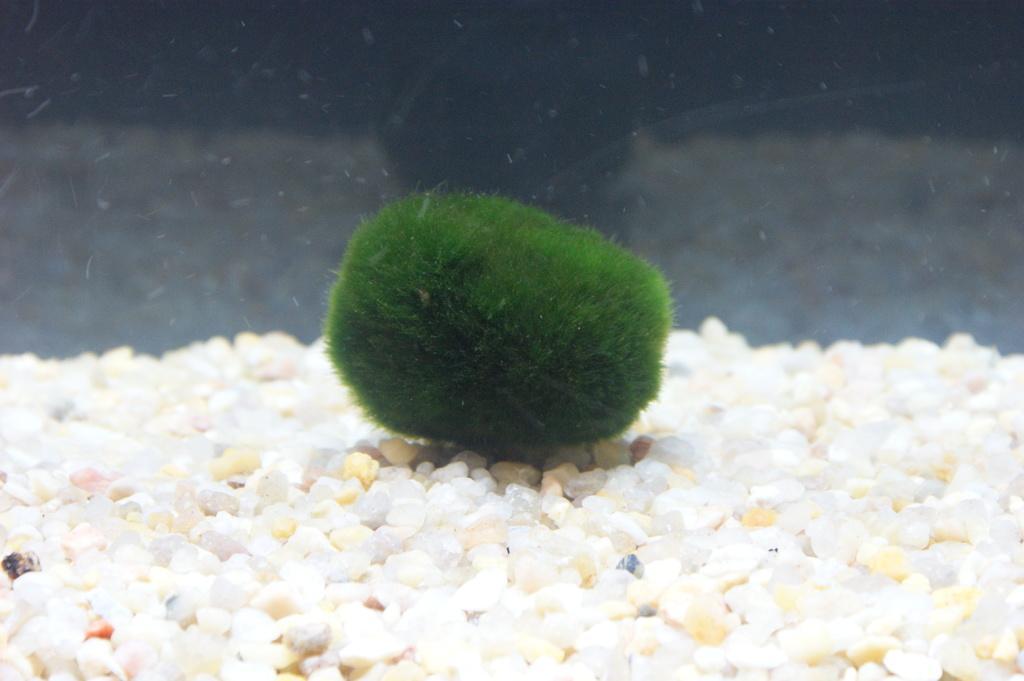What is the color of the object in the image? The object in the image is green. What else can be seen in the image besides the green object? There are stones in the image. What type of mist can be seen surrounding the green object in the image? There is no mist present in the image; it only features a green object and stones. How does the muscle appear in the image? There is no muscle present in the image. 